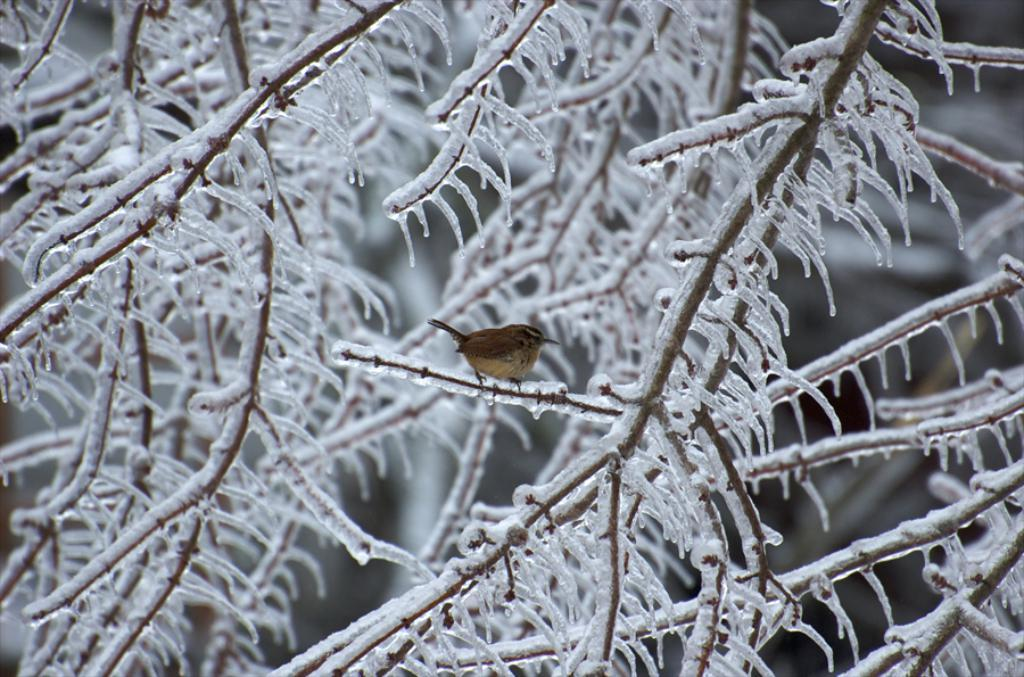What type of natural elements are present in the image? There are frozen branches in the image. Are there any animals visible in the image? Yes, there is a bird in the image. Can you describe the background of the image? The background of the image is blurry. What type of quartz can be seen in the image? There is no quartz present in the image. How does the bird say good-bye in the image? Birds do not have the ability to say good-bye, and there is no indication of any interaction between the bird and the viewer in the image. 